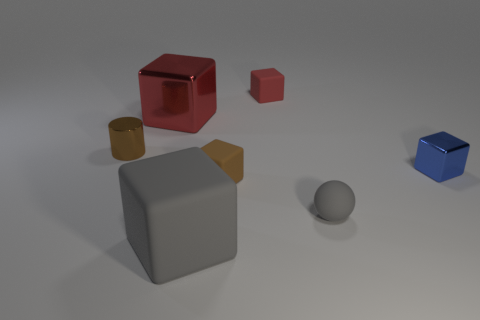Subtract 1 blocks. How many blocks are left? 4 Subtract all gray cubes. How many cubes are left? 4 Subtract all large red metallic blocks. How many blocks are left? 4 Subtract all purple blocks. Subtract all brown spheres. How many blocks are left? 5 Add 2 tiny brown cylinders. How many objects exist? 9 Subtract all blocks. How many objects are left? 2 Subtract 0 purple cylinders. How many objects are left? 7 Subtract all big brown matte cylinders. Subtract all brown rubber cubes. How many objects are left? 6 Add 6 red matte cubes. How many red matte cubes are left? 7 Add 5 small red rubber blocks. How many small red rubber blocks exist? 6 